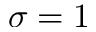Convert formula to latex. <formula><loc_0><loc_0><loc_500><loc_500>\sigma = 1</formula> 